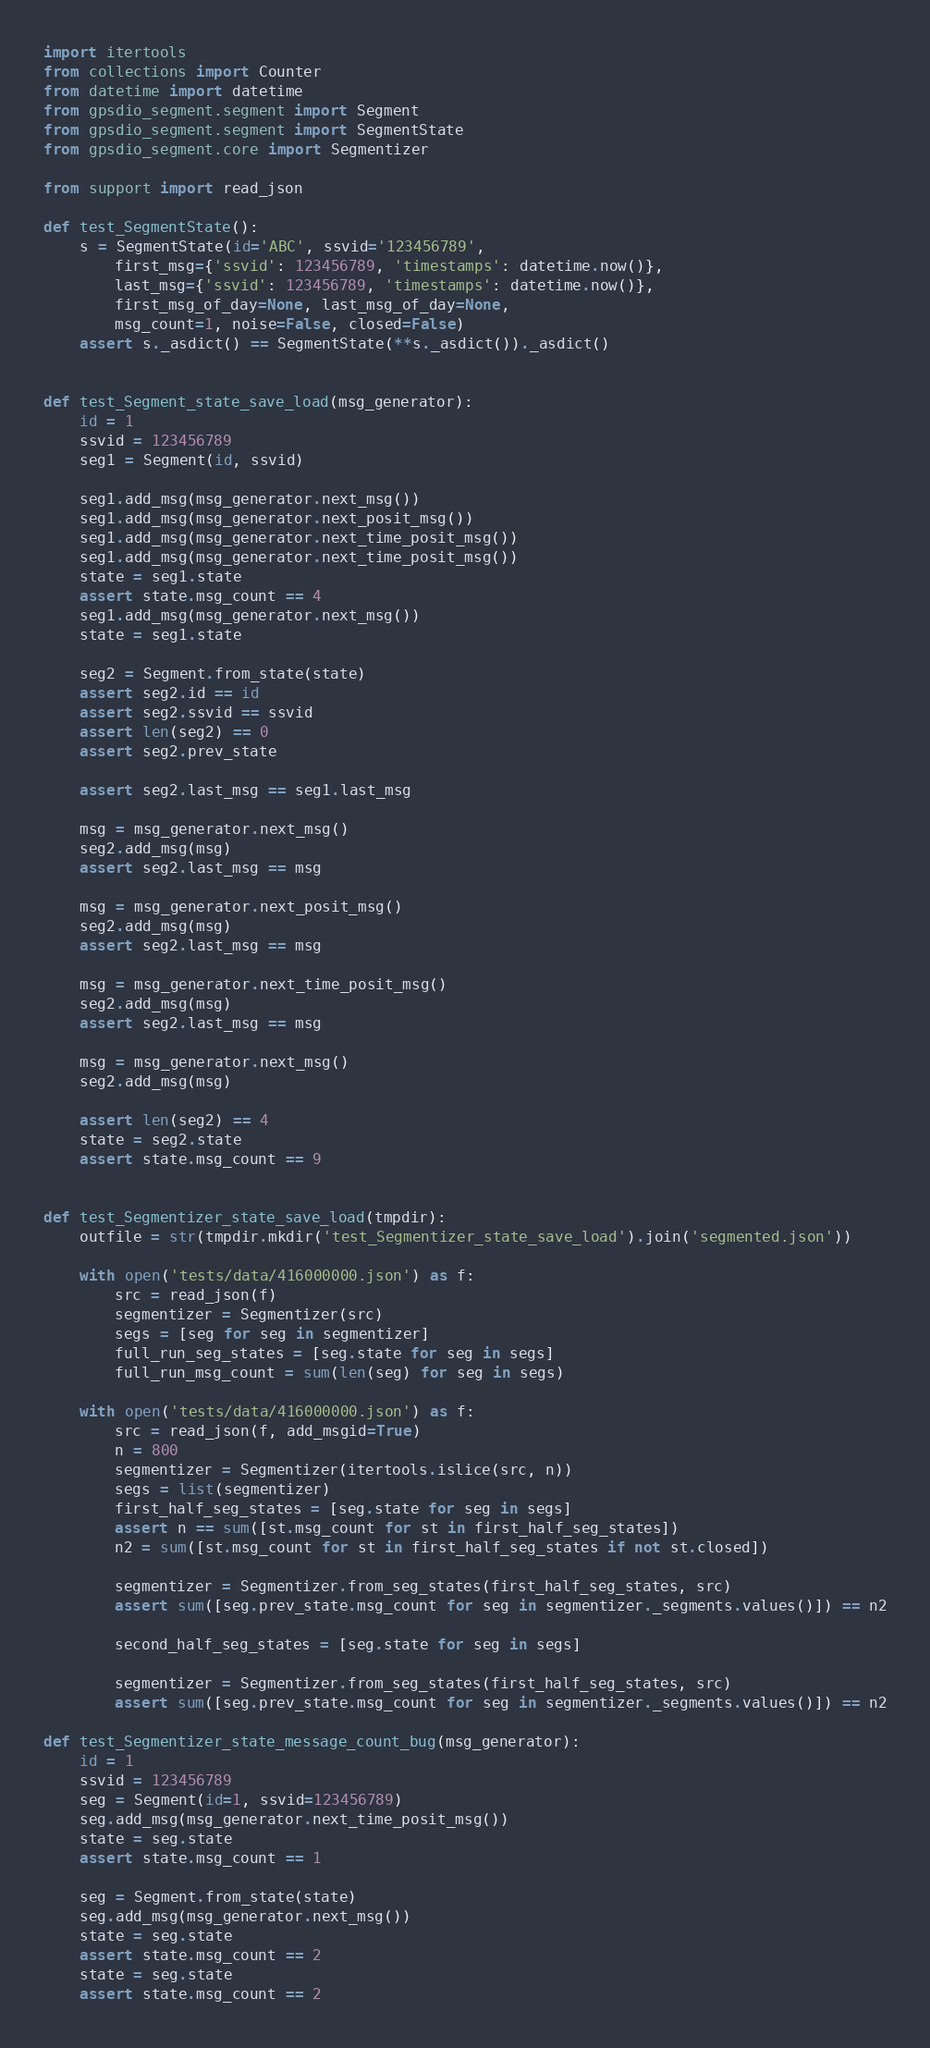<code> <loc_0><loc_0><loc_500><loc_500><_Python_>import itertools
from collections import Counter
from datetime import datetime
from gpsdio_segment.segment import Segment
from gpsdio_segment.segment import SegmentState
from gpsdio_segment.core import Segmentizer

from support import read_json

def test_SegmentState():
    s = SegmentState(id='ABC', ssvid='123456789', 
        first_msg={'ssvid': 123456789, 'timestamps': datetime.now()},
        last_msg={'ssvid': 123456789, 'timestamps': datetime.now()},
        first_msg_of_day=None, last_msg_of_day=None,
        msg_count=1, noise=False, closed=False)
    assert s._asdict() == SegmentState(**s._asdict())._asdict()


def test_Segment_state_save_load(msg_generator):
    id = 1
    ssvid = 123456789
    seg1 = Segment(id, ssvid)

    seg1.add_msg(msg_generator.next_msg())
    seg1.add_msg(msg_generator.next_posit_msg())
    seg1.add_msg(msg_generator.next_time_posit_msg())
    seg1.add_msg(msg_generator.next_time_posit_msg())
    state = seg1.state
    assert state.msg_count == 4
    seg1.add_msg(msg_generator.next_msg())
    state = seg1.state

    seg2 = Segment.from_state(state)
    assert seg2.id == id
    assert seg2.ssvid == ssvid
    assert len(seg2) == 0
    assert seg2.prev_state

    assert seg2.last_msg == seg1.last_msg

    msg = msg_generator.next_msg()
    seg2.add_msg(msg)
    assert seg2.last_msg == msg

    msg = msg_generator.next_posit_msg()
    seg2.add_msg(msg)
    assert seg2.last_msg == msg

    msg = msg_generator.next_time_posit_msg()
    seg2.add_msg(msg)
    assert seg2.last_msg == msg

    msg = msg_generator.next_msg()
    seg2.add_msg(msg)

    assert len(seg2) == 4
    state = seg2.state
    assert state.msg_count == 9


def test_Segmentizer_state_save_load(tmpdir):
    outfile = str(tmpdir.mkdir('test_Segmentizer_state_save_load').join('segmented.json'))

    with open('tests/data/416000000.json') as f:
        src = read_json(f)
        segmentizer = Segmentizer(src)
        segs = [seg for seg in segmentizer]
        full_run_seg_states = [seg.state for seg in segs]
        full_run_msg_count = sum(len(seg) for seg in segs)

    with open('tests/data/416000000.json') as f:
        src = read_json(f, add_msgid=True)
        n = 800
        segmentizer = Segmentizer(itertools.islice(src, n))
        segs = list(segmentizer)
        first_half_seg_states = [seg.state for seg in segs]
        assert n == sum([st.msg_count for st in first_half_seg_states])
        n2 = sum([st.msg_count for st in first_half_seg_states if not st.closed])

        segmentizer = Segmentizer.from_seg_states(first_half_seg_states, src)
        assert sum([seg.prev_state.msg_count for seg in segmentizer._segments.values()]) == n2

        second_half_seg_states = [seg.state for seg in segs]

        segmentizer = Segmentizer.from_seg_states(first_half_seg_states, src)
        assert sum([seg.prev_state.msg_count for seg in segmentizer._segments.values()]) == n2

def test_Segmentizer_state_message_count_bug(msg_generator):
    id = 1
    ssvid = 123456789
    seg = Segment(id=1, ssvid=123456789)
    seg.add_msg(msg_generator.next_time_posit_msg())
    state = seg.state
    assert state.msg_count == 1

    seg = Segment.from_state(state)
    seg.add_msg(msg_generator.next_msg())
    state = seg.state
    assert state.msg_count == 2
    state = seg.state
    assert state.msg_count == 2
</code> 